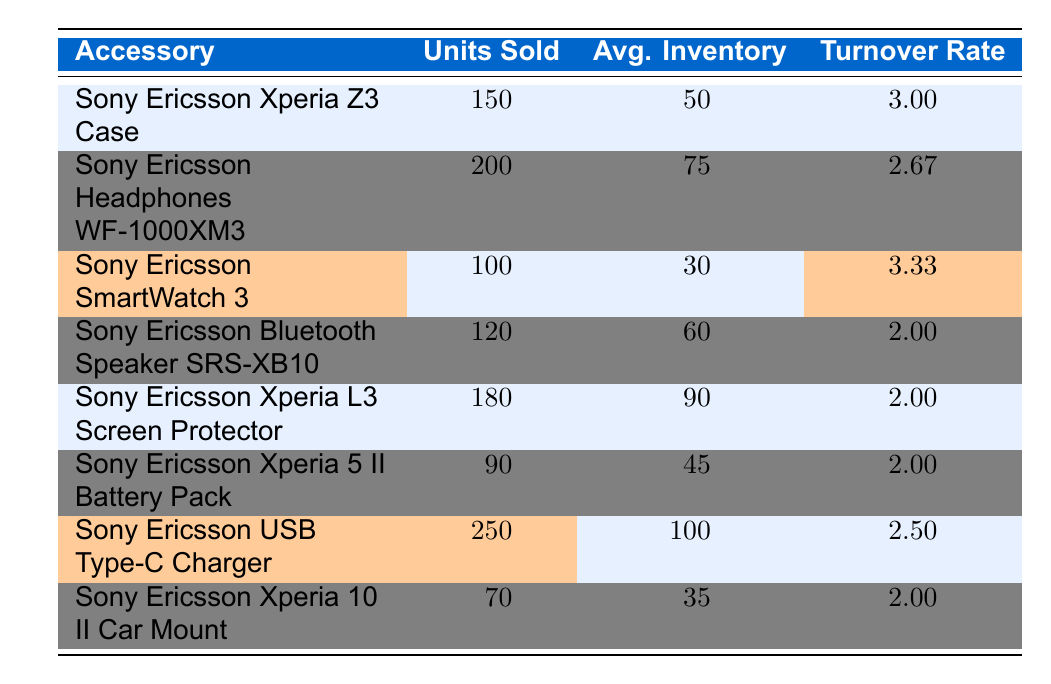What is the highest inventory turnover rate among the accessories? The highest turnover rate is 3.33, which corresponds to the "Sony Ericsson SmartWatch 3." I identified the values in the "Turnover Rate" column and noted that 3.33 is the maximum value.
Answer: 3.33 How many units of the Sony Ericsson USB Type-C Charger were sold? The "Units Sold" for the Sony Ericsson USB Type-C Charger is listed as 250. I found this information by looking up the accessory and checking its corresponding value in the table.
Answer: 250 What was the average inventory for the Sony Ericsson Xperia Z3 Case? The average inventory for the Sony Ericsson Xperia Z3 Case is 50 units. This value is directly listed in the table alongside the accessory.
Answer: 50 Which accessory had the lowest inventory turnover rate, and what was that rate? The lowest turnover rate among the accessories is 2.00, which is shared by multiple items: "Sony Ericsson Bluetooth Speaker SRS-XB10," "Sony Ericsson Xperia L3 Screen Protector," "Sony Ericsson Xperia 5 II Battery Pack," and "Sony Ericsson Xperia 10 II Car Mount." I reviewed all listed turnover rates and identified the minimum.
Answer: 2.00 What is the total number of units sold for all accessories combined? To find the total, I summed the "Units Sold" values: 150 + 200 + 100 + 120 + 180 + 90 + 250 + 70 = 1160 units total. Each unit count was retrieved from the table for calculation.
Answer: 1160 Is the turnover rate for the Sony Ericsson Headphones WF-1000XM3 greater than the average turnover rate for all items? First, I need to calculate the average turnover rate. The total turnover rates sum to 3.0 + 2.67 + 3.33 + 2.0 + 2.0 + 2.0 + 2.5 + 2.0 = 19.5, and dividing by 8 items gives an average of 2.4375. The Headphones' turnover rate is 2.67, which is greater than 2.4375. I compared both values to answer.
Answer: Yes How many accessories had a turnover rate higher than 2.5? I checked each accessory's turnover rate and found that two have a turnover rate higher than 2.5: "Sony Ericsson SmartWatch 3" (3.33) and "Sony Ericsson Xperia Z3 Case" (3.0). Thus, there are two accessories meeting the criterion.
Answer: 2 What percentage of units sold for the Sony Ericsson USB Type-C Charger compared to the total units sold? The percentage is calculated as (Units Sold for USB Type-C Charger / Total Units Sold) * 100 = (250 / 1160) * 100 ≈ 21.55%. I took the Chargers' units and computed it relative to the total obtained earlier.
Answer: ~21.55% 